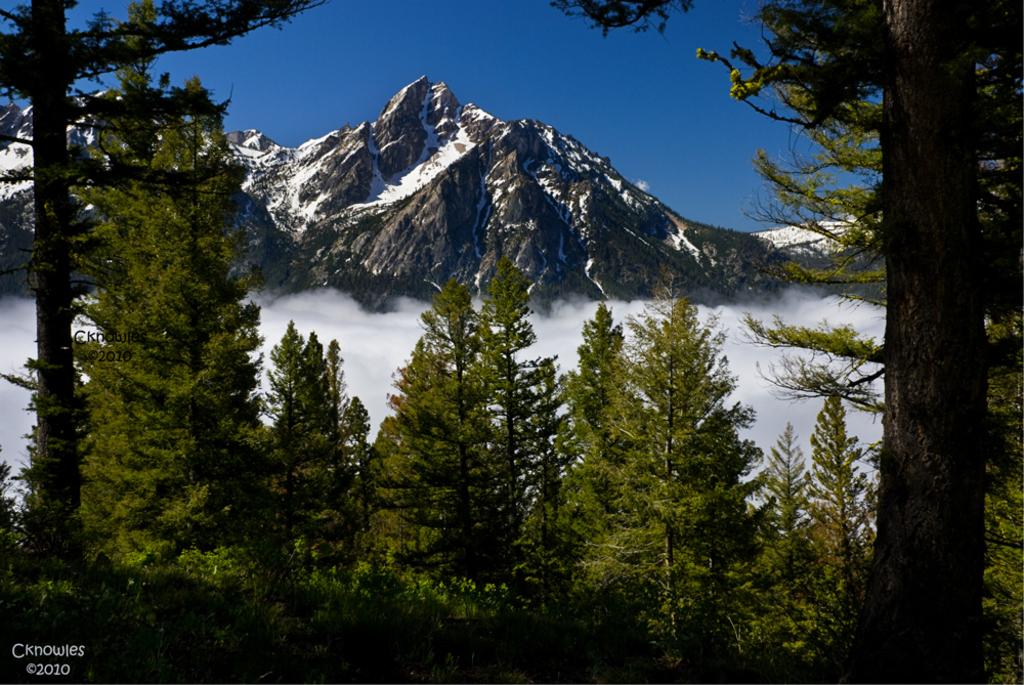What can be seen in the background of the image? There is a clear blue sky in the background of the image. What geographical features are visible in the image? There are mountains with peaks in the image. What type of vegetation is present in the image? Trees are present in the image. Can you describe any additional elements in the image? There is a watermark in the bottom left corner of the image. What color is the root of the orange tree in the image? There is no orange tree or root present in the image. How many eggs are visible in the image? There are no eggs visible in the image. 